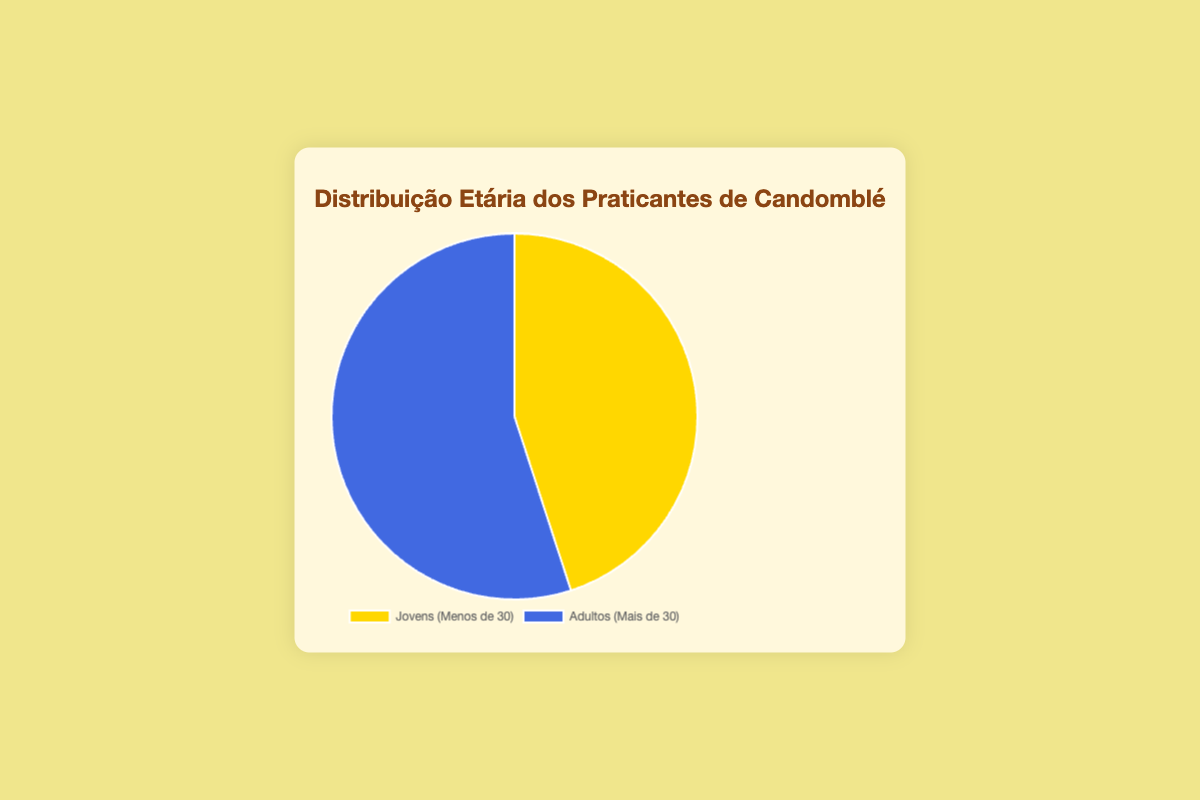What percentage of Candomblé practitioners are Youth (Under 30)? From the pie chart, it is indicated that Youth (Under 30) make up 45% of the total practitioners.
Answer: 45% Which age group has a larger proportion of practitioners, Youth (Under 30) or Adults (Over 30)? The pie chart shows that Adults (Over 30) make up 55% while Youth (Under 30) make up 45%. Therefore, Adults have a larger proportion.
Answer: Adults (Over 30) How many more Adult practitioners (Over 30) are there compared to Youth practitioners (Under 30)? Adults practitioners are 55% and Youth practitioners are 45%, making the difference 55% - 45% = 10%. Given the total number of practitioners is (150 + 180 = 330), the difference in actual numbers is (180 - 150 = 30).
Answer: 30 If we were to sum up the practitioners of both age groups, what would be the total percentage? The pie chart shows percentages for both groups, summing up to 45% + 55% = 100%.
Answer: 100% What is the ratio of Youth practitioners to Adult practitioners? The ratio is calculated by dividing the number of Youth practitioners by the number of Adult practitioners: 150 / 180 = 5/6.
Answer: 5:6 Which age group segment is represented with a blue color? The pie chart uses blue to depict the Adults (Over 30) group.
Answer: Adults (Over 30) What would the percentage of Youth practitioners be if 30 more Youth practitioners joined? With 30 more Youth, the new count would be 150 + 30 = 180. The total count would be 180 (Youth) + 180 (Adults) = 360. New Youth percentage = (180/360) * 100% = 50%.
Answer: 50% By what percentage do Adults (Over 30) exceed Youth (Under 30) practitioners? Adults (Over 30) exceed Youth (Under 30) by a difference of 55% - 45% = 10%.
Answer: 10% If the percentage of Youth were to increase to 48%, what would be the corresponding percentage of Adults? In a pie chart, the total percentage is always 100%. If Youth is 48%, Adults would be 100% - 48% = 52%.
Answer: 52% Is the segment representing Youth practitioners smaller or larger than the segment representing Adult practitioners? The segment representing Youth practitioners is smaller since it shows 45% compared to the Adults' 55%.
Answer: Smaller 